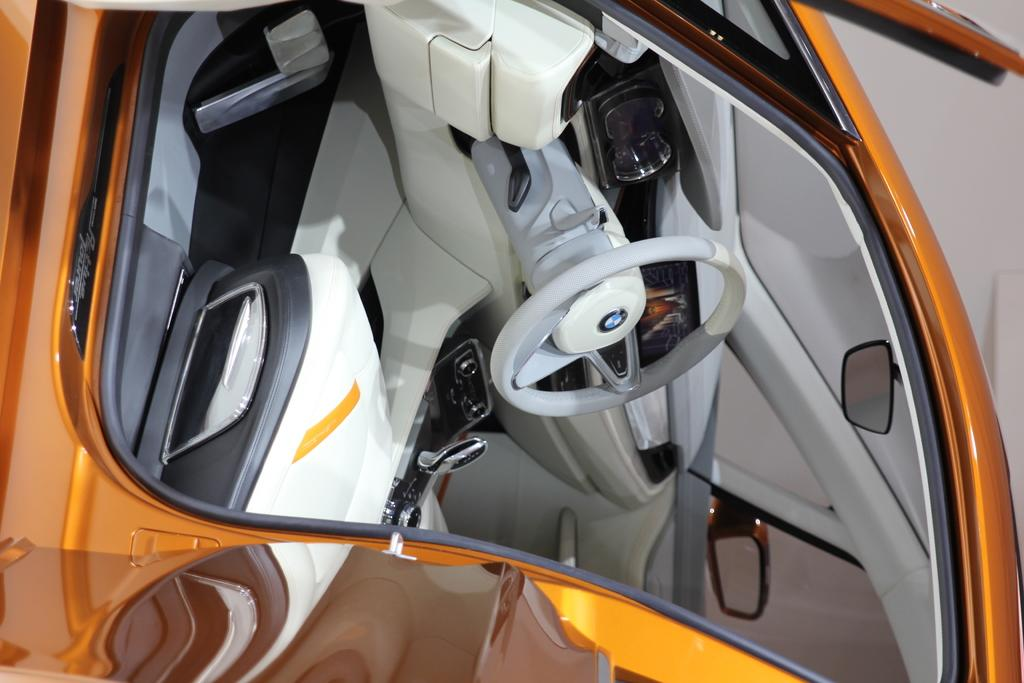What is the main subject of the image? There is a car in the image. How many vacation days does the car offer to its passengers? The car is an inanimate object and does not offer vacation days. 